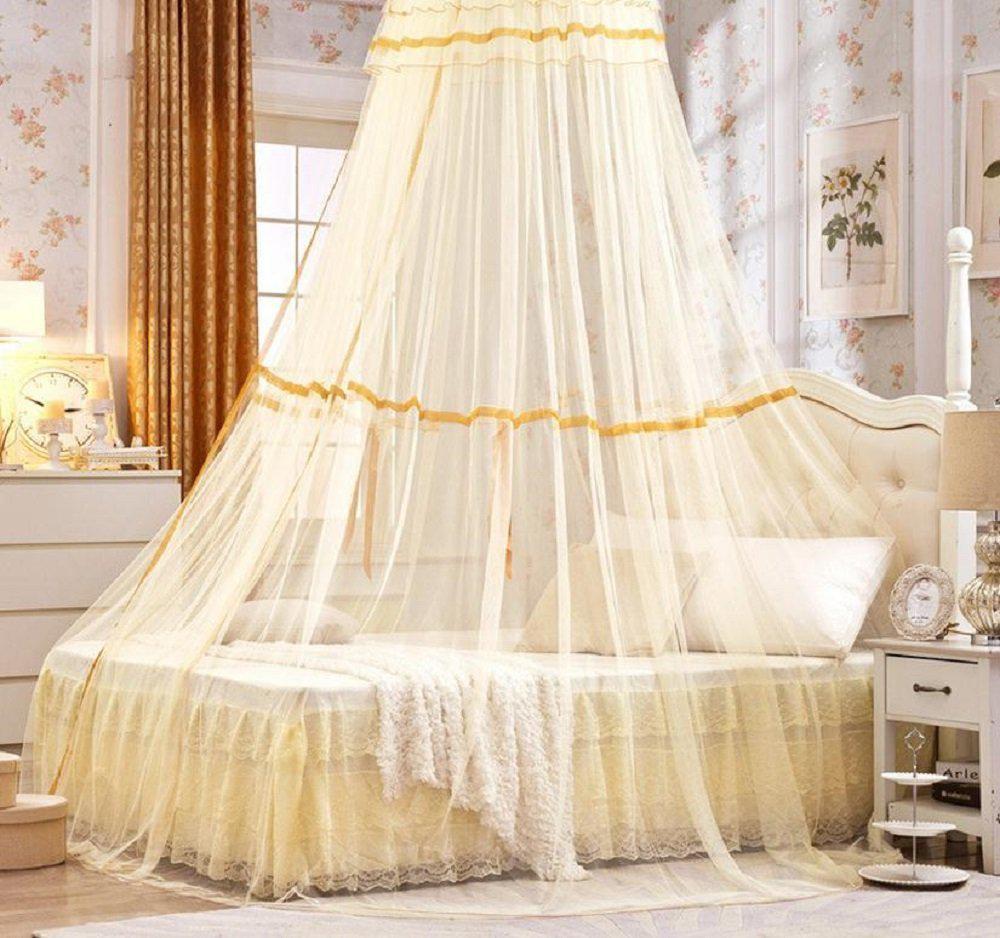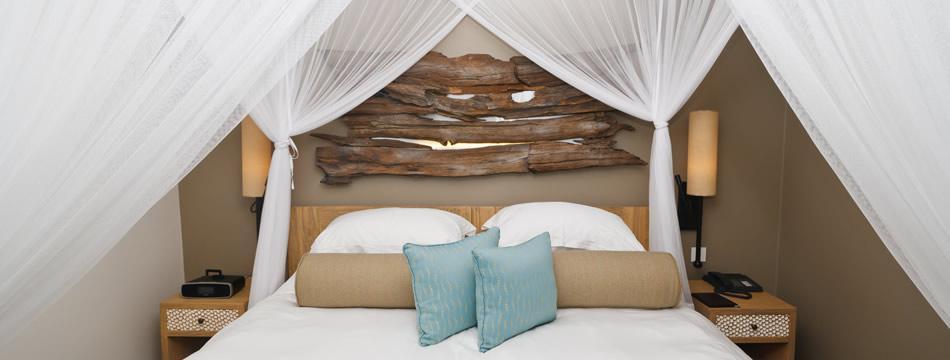The first image is the image on the left, the second image is the image on the right. Given the left and right images, does the statement "Two blue pillows are on a bed under a sheer white canopy that ties at the corners." hold true? Answer yes or no. Yes. The first image is the image on the left, the second image is the image on the right. Analyze the images presented: Is the assertion "There is no more than 5 pillows." valid? Answer yes or no. No. 